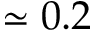Convert formula to latex. <formula><loc_0><loc_0><loc_500><loc_500>\simeq 0 . 2</formula> 